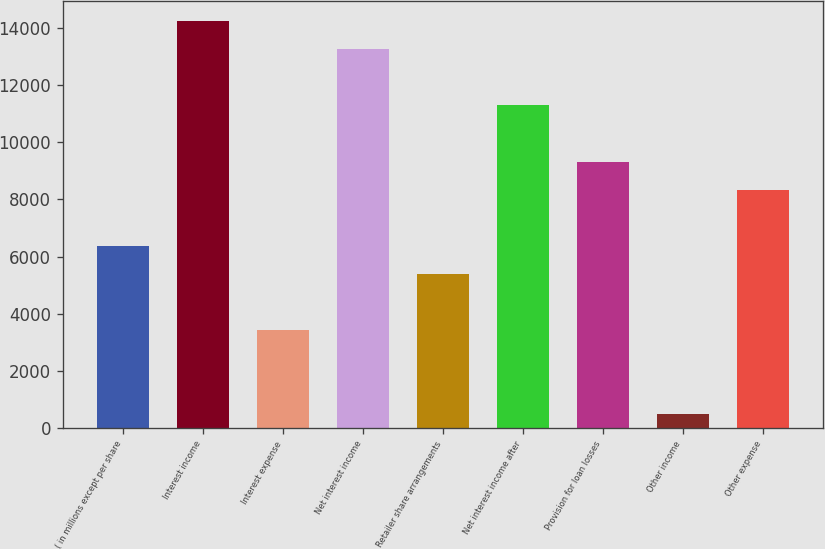Convert chart. <chart><loc_0><loc_0><loc_500><loc_500><bar_chart><fcel>( in millions except per share<fcel>Interest income<fcel>Interest expense<fcel>Net interest income<fcel>Retailer share arrangements<fcel>Net interest income after<fcel>Provision for loan losses<fcel>Other income<fcel>Other expense<nl><fcel>6379<fcel>14239<fcel>3431.5<fcel>13256.5<fcel>5396.5<fcel>11291.5<fcel>9326.5<fcel>484<fcel>8344<nl></chart> 